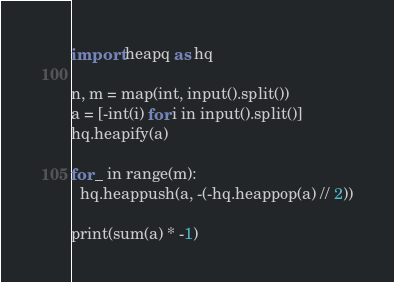<code> <loc_0><loc_0><loc_500><loc_500><_Python_>import heapq as hq

n, m = map(int, input().split())
a = [-int(i) for i in input().split()]
hq.heapify(a)

for _ in range(m):
  hq.heappush(a, -(-hq.heappop(a) // 2))
  
print(sum(a) * -1)
</code> 